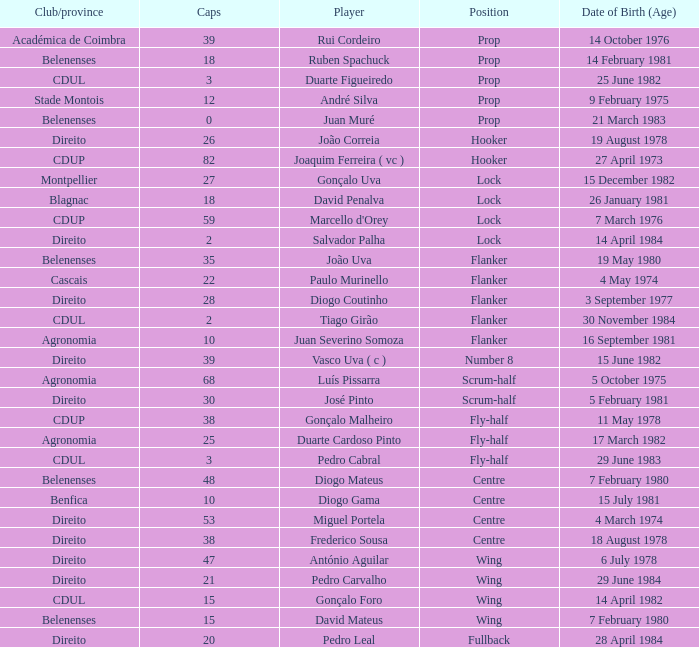Could you parse the entire table as a dict? {'header': ['Club/province', 'Caps', 'Player', 'Position', 'Date of Birth (Age)'], 'rows': [['Académica de Coimbra', '39', 'Rui Cordeiro', 'Prop', '14 October 1976'], ['Belenenses', '18', 'Ruben Spachuck', 'Prop', '14 February 1981'], ['CDUL', '3', 'Duarte Figueiredo', 'Prop', '25 June 1982'], ['Stade Montois', '12', 'André Silva', 'Prop', '9 February 1975'], ['Belenenses', '0', 'Juan Muré', 'Prop', '21 March 1983'], ['Direito', '26', 'João Correia', 'Hooker', '19 August 1978'], ['CDUP', '82', 'Joaquim Ferreira ( vc )', 'Hooker', '27 April 1973'], ['Montpellier', '27', 'Gonçalo Uva', 'Lock', '15 December 1982'], ['Blagnac', '18', 'David Penalva', 'Lock', '26 January 1981'], ['CDUP', '59', "Marcello d'Orey", 'Lock', '7 March 1976'], ['Direito', '2', 'Salvador Palha', 'Lock', '14 April 1984'], ['Belenenses', '35', 'João Uva', 'Flanker', '19 May 1980'], ['Cascais', '22', 'Paulo Murinello', 'Flanker', '4 May 1974'], ['Direito', '28', 'Diogo Coutinho', 'Flanker', '3 September 1977'], ['CDUL', '2', 'Tiago Girão', 'Flanker', '30 November 1984'], ['Agronomia', '10', 'Juan Severino Somoza', 'Flanker', '16 September 1981'], ['Direito', '39', 'Vasco Uva ( c )', 'Number 8', '15 June 1982'], ['Agronomia', '68', 'Luís Pissarra', 'Scrum-half', '5 October 1975'], ['Direito', '30', 'José Pinto', 'Scrum-half', '5 February 1981'], ['CDUP', '38', 'Gonçalo Malheiro', 'Fly-half', '11 May 1978'], ['Agronomia', '25', 'Duarte Cardoso Pinto', 'Fly-half', '17 March 1982'], ['CDUL', '3', 'Pedro Cabral', 'Fly-half', '29 June 1983'], ['Belenenses', '48', 'Diogo Mateus', 'Centre', '7 February 1980'], ['Benfica', '10', 'Diogo Gama', 'Centre', '15 July 1981'], ['Direito', '53', 'Miguel Portela', 'Centre', '4 March 1974'], ['Direito', '38', 'Frederico Sousa', 'Centre', '18 August 1978'], ['Direito', '47', 'António Aguilar', 'Wing', '6 July 1978'], ['Direito', '21', 'Pedro Carvalho', 'Wing', '29 June 1984'], ['CDUL', '15', 'Gonçalo Foro', 'Wing', '14 April 1982'], ['Belenenses', '15', 'David Mateus', 'Wing', '7 February 1980'], ['Direito', '20', 'Pedro Leal', 'Fullback', '28 April 1984']]} How many caps have a Position of prop, and a Player of rui cordeiro? 1.0. 